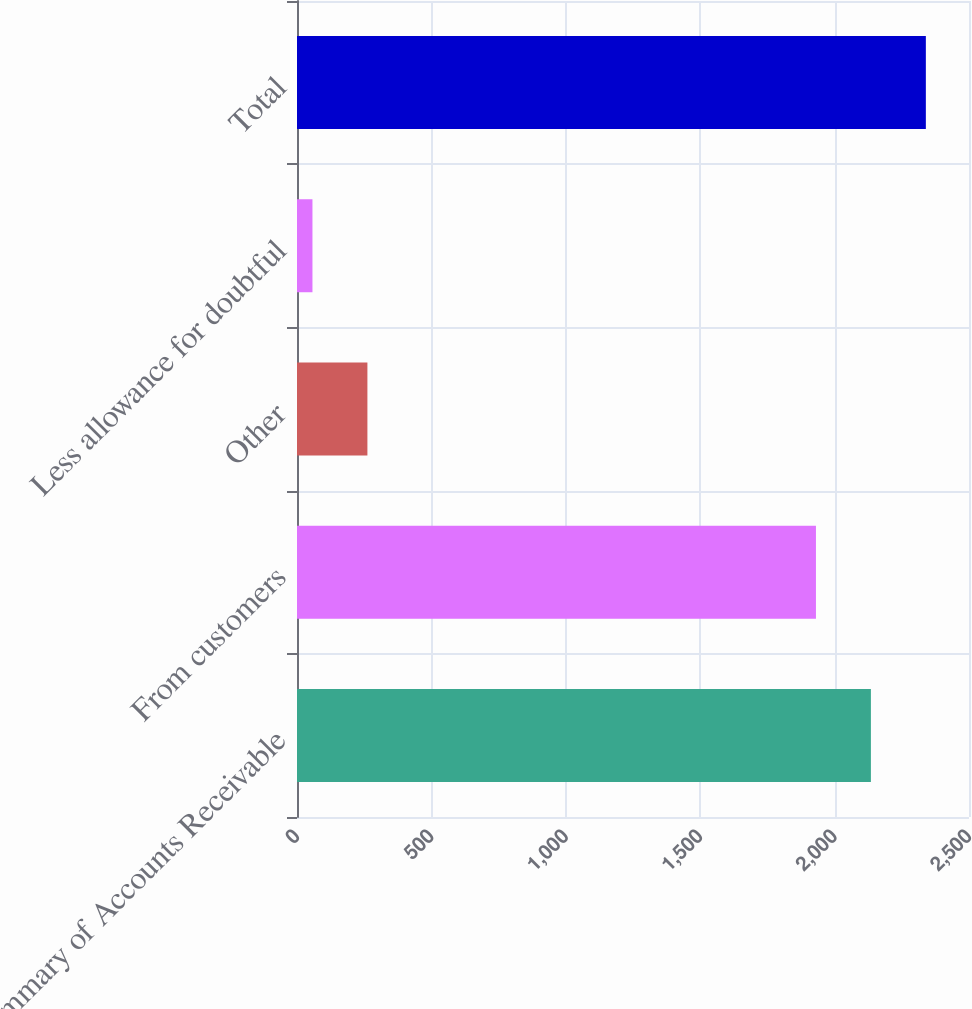<chart> <loc_0><loc_0><loc_500><loc_500><bar_chart><fcel>Summary of Accounts Receivable<fcel>From customers<fcel>Other<fcel>Less allowance for doubtful<fcel>Total<nl><fcel>2135.04<fcel>1930.6<fcel>261.94<fcel>57.5<fcel>2339.48<nl></chart> 